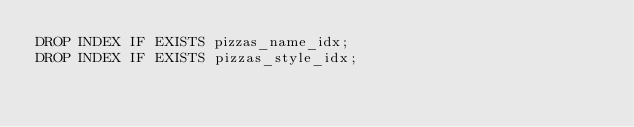Convert code to text. <code><loc_0><loc_0><loc_500><loc_500><_SQL_>DROP INDEX IF EXISTS pizzas_name_idx;
DROP INDEX IF EXISTS pizzas_style_idx;</code> 